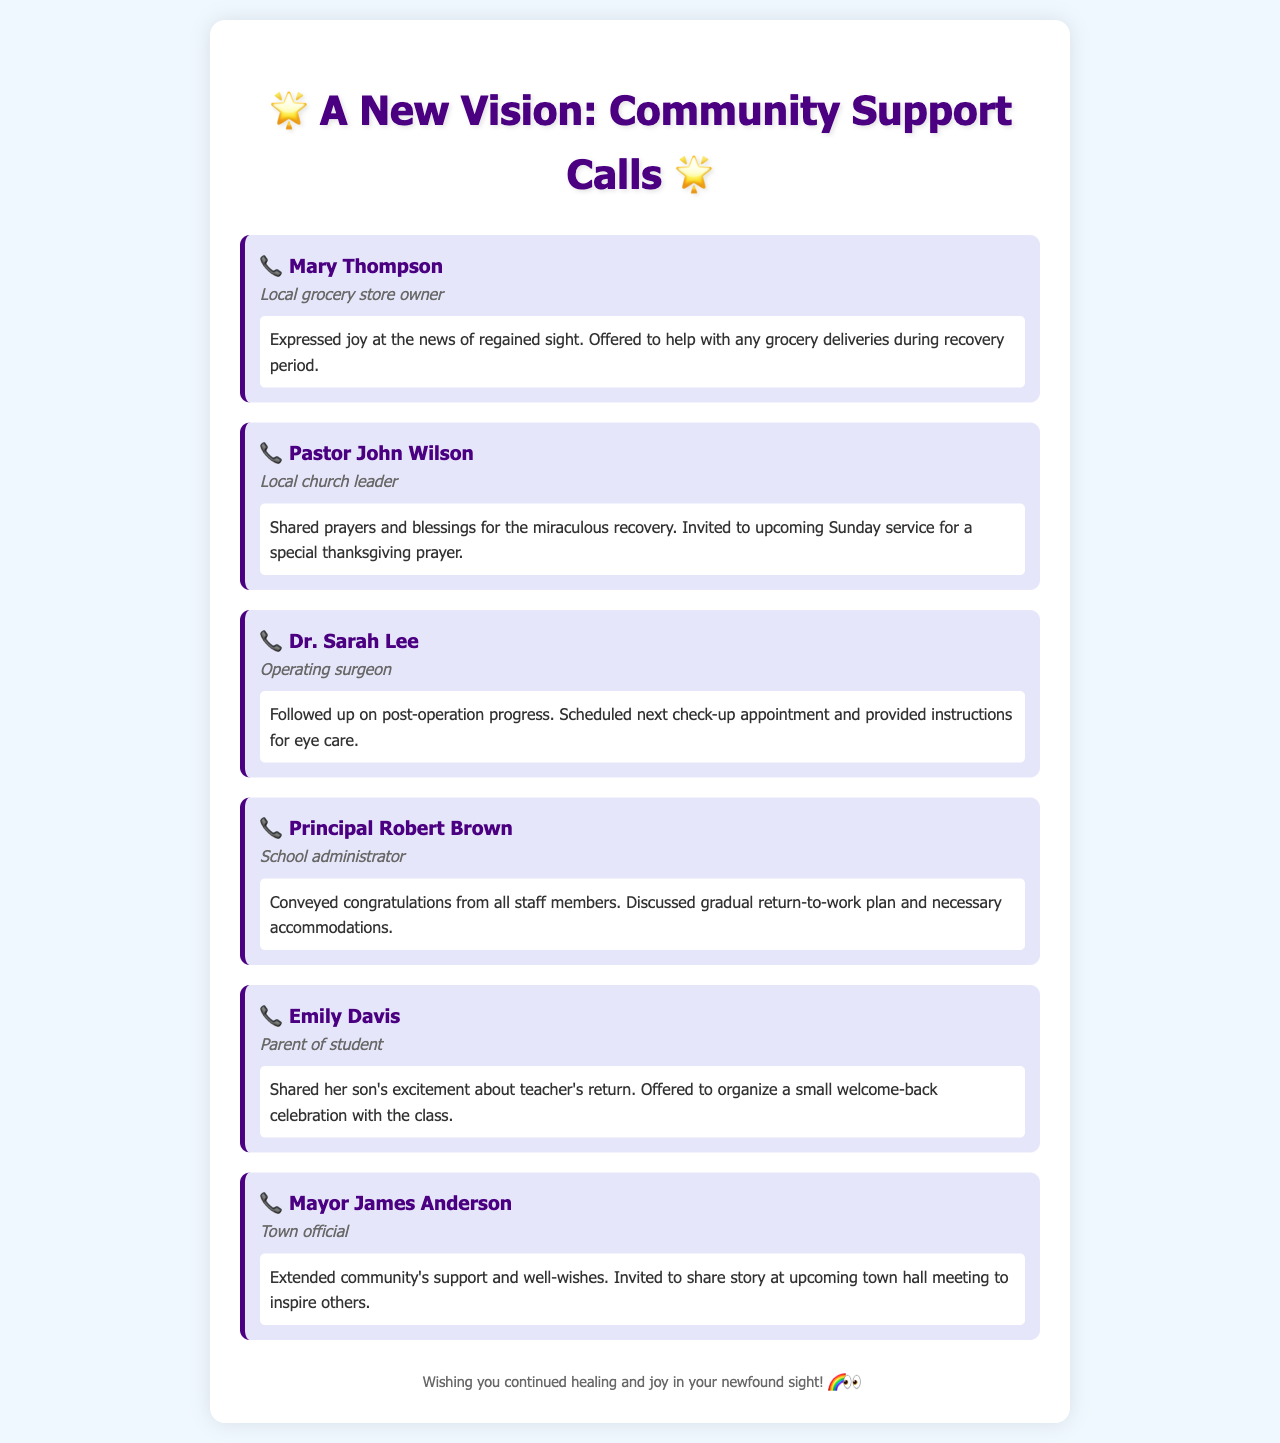what is the name of the grocery store owner? Mary Thompson is identified as the local grocery store owner in the document.
Answer: Mary Thompson who is the local church leader? Pastor John Wilson is mentioned as the local church leader in the calls.
Answer: Pastor John Wilson how did Dr. Sarah Lee contribute to the document? Dr. Sarah Lee followed up on the post-operation progress, providing instructions and scheduling a check-up.
Answer: Followed up on post-operation what did Emily Davis offer to organize? Emily Davis offered to organize a small welcome-back celebration for the teacher.
Answer: Welcome-back celebration who invited you to share your story? Mayor James Anderson extended the invitation to share the story at an upcoming town hall meeting.
Answer: Mayor James Anderson what did Principal Robert Brown discuss? Principal Robert Brown discussed a gradual return-to-work plan and necessary accommodations.
Answer: Gradual return-to-work plan how did the community respond to the news of regained sight? The community expressed joy and support in various phone calls about the regained sight.
Answer: Joy and support which role does Mary Thompson hold in the community? Mary Thompson is identified as a local grocery store owner in the document.
Answer: Grocery store owner what type of relationship does Dr. Sarah Lee have with the caller? Dr. Sarah Lee is the operating surgeon, establishing a professional relationship with the caller.
Answer: Operating surgeon 